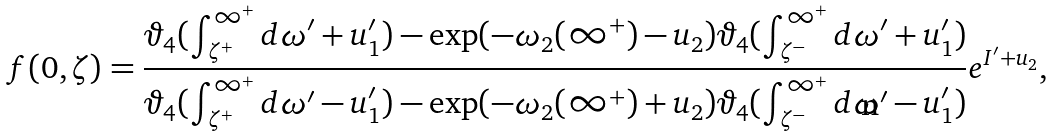<formula> <loc_0><loc_0><loc_500><loc_500>f ( 0 , \zeta ) = \frac { \vartheta _ { 4 } ( \int _ { \zeta ^ { + } } ^ { \infty ^ { + } } d \omega ^ { \prime } + u _ { 1 } ^ { \prime } ) - \exp ( - \omega _ { 2 } ( \infty ^ { + } ) - u _ { 2 } ) \vartheta _ { 4 } ( \int _ { \zeta ^ { - } } ^ { \infty ^ { + } } d \omega ^ { \prime } + u _ { 1 } ^ { \prime } ) } { \vartheta _ { 4 } ( \int _ { \zeta ^ { + } } ^ { \infty ^ { + } } d \omega ^ { \prime } - u _ { 1 } ^ { \prime } ) - \exp ( - \omega _ { 2 } ( \infty ^ { + } ) + u _ { 2 } ) \vartheta _ { 4 } ( \int _ { \zeta ^ { - } } ^ { \infty ^ { + } } d \omega ^ { \prime } - u _ { 1 } ^ { \prime } ) } e ^ { I ^ { \prime } + u _ { 2 } } ,</formula> 